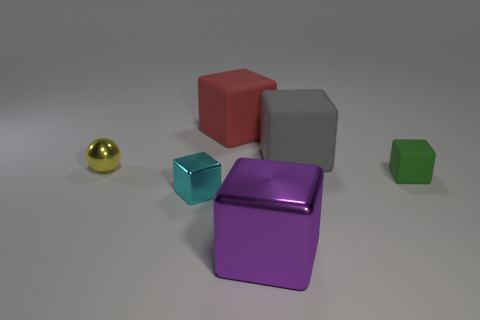Subtract all red blocks. How many blocks are left? 4 Add 2 red cubes. How many red cubes exist? 3 Add 2 big green metal balls. How many objects exist? 8 Subtract all cyan blocks. How many blocks are left? 4 Subtract 1 green blocks. How many objects are left? 5 Subtract all cubes. How many objects are left? 1 Subtract 2 blocks. How many blocks are left? 3 Subtract all green cubes. Subtract all green cylinders. How many cubes are left? 4 Subtract all yellow blocks. How many red spheres are left? 0 Subtract all large cubes. Subtract all red things. How many objects are left? 2 